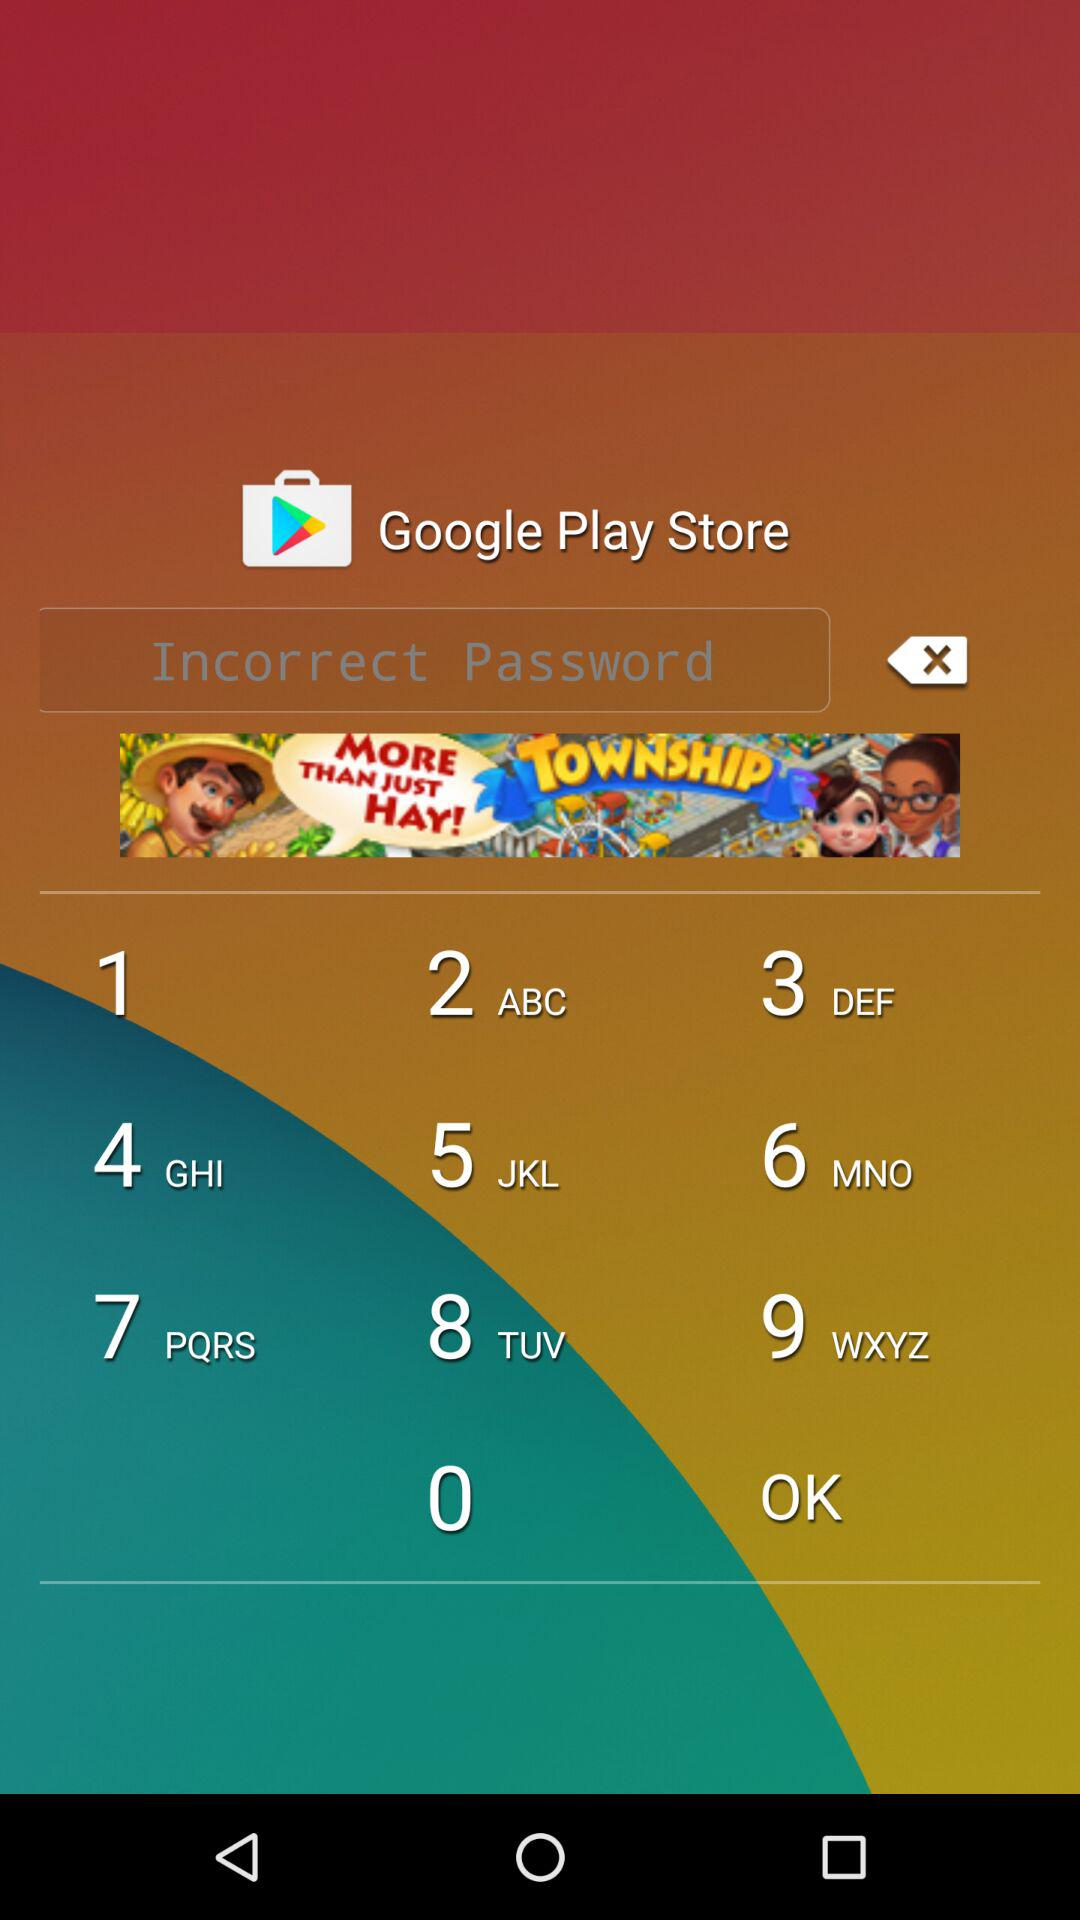In which city was the application made? The application was made in Porto Alegre. 